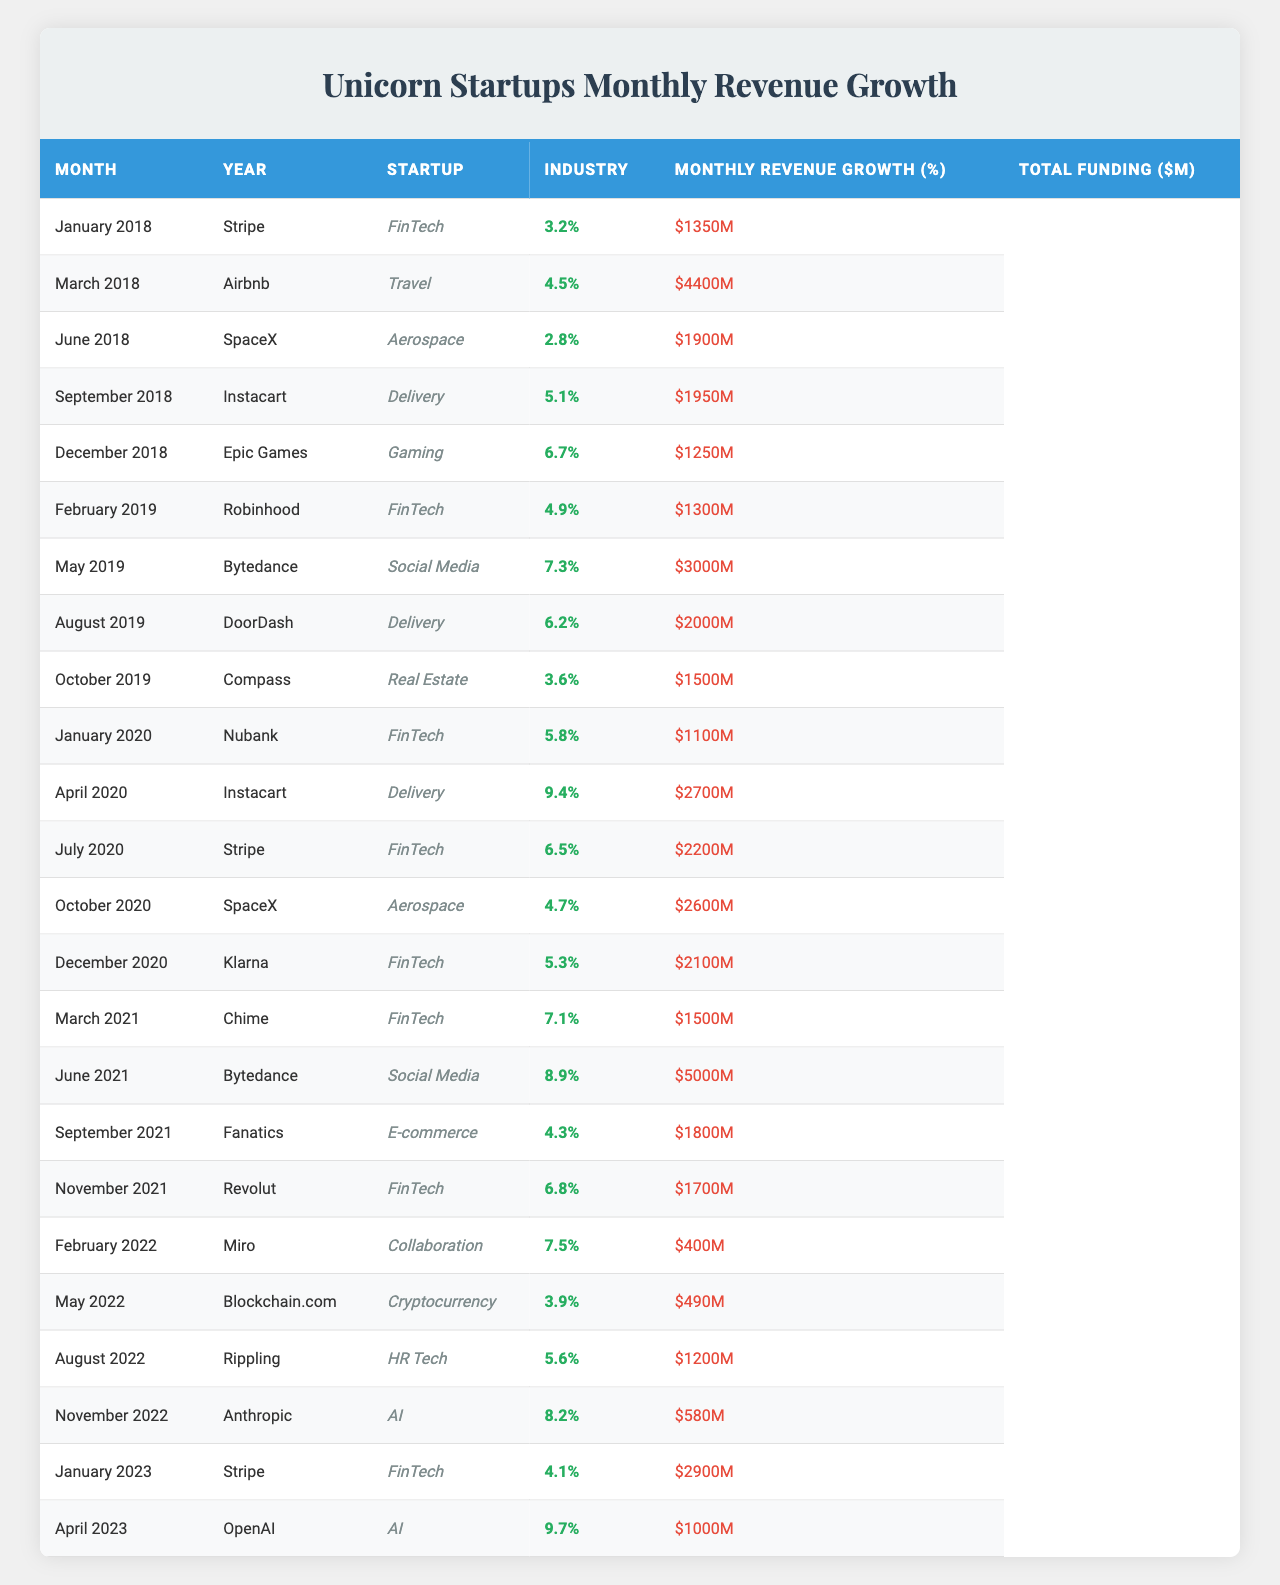What was the highest monthly revenue growth percentage recorded in the table? Scanning through the "Monthly Revenue Growth (%)" column, the highest value is 9.7%, which corresponds to OpenAI in April 2023.
Answer: 9.7% Which startup had the lowest total funding in the table? By checking the "Total Funding ($M)" column, the lowest value is $400M, which corresponds to Miro in February 2022.
Answer: $400M What was the average monthly revenue growth for the FinTech industry? The FinTech startups listed and their growth percentages are: 3.2%, 4.9%, 5.8%, 6.5%, 5.3%, 7.1%, and 6.8%. Summing these values gives 39.6%, dividing by the 7 entries yields an average of 39.6/7 = 5.657%.
Answer: 5.66% Did SpaceX have a month where their monthly revenue growth exceeded 5%? Looking at SpaceX's entries, the values are 2.8% in June 2018 and 4.7% in October 2020. Both are below 5%, which means they never exceeded this growth percentage.
Answer: No Which startup saw a significant increase in monthly revenue growth from 2019 to 2020? Comparing the growth rates from these years, DoorDash had 6.2% in August 2019 and then in April 2020, Instacart grew to 9.4%, illustrating significant growth.
Answer: Instacart How many industries had startups with monthly revenue growth of over 8%? By reviewing the table, the industries with growth over 8% are AI (OpenAI and Anthropic), and Social Media (Bytedance). This represents a total of 3 unique industries with growth rates above 8%.
Answer: 3 What is the total funding for all the startups listed in the table? Summing up the total funding amounts from the table yields a total of $33,600 million.
Answer: $33,600M How does Airbnb's revenue growth in March 2018 compare to the same month in subsequent years? In March 2018, Airbnb's growth was 4.5%. No other entries for Airbnb are present in March for subsequent years, so we can't directly compare. The answer remains 4.5% as a single value.
Answer: 4.5% Which startup had the largest increase in monthly revenue growth from 2019 to 2020? Analyzing the growth in 2019 versus 2020, Instacart showed an increase from 6.2% in August 2019 to 9.4% in April 2020; thus, it had the largest increase during this period.
Answer: Instacart Was there any startup that consistently demonstrated monthly revenue growth above 5% in every entry of the table? Upon reviewing the values, only Bytedance reached above 5% in its entries. Thus, not all startups kept a consistent growth above this threshold.
Answer: No 